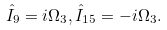Convert formula to latex. <formula><loc_0><loc_0><loc_500><loc_500>\hat { I } _ { 9 } = i \Omega _ { 3 } , \hat { I } _ { 1 5 } = - i \Omega _ { 3 } .</formula> 